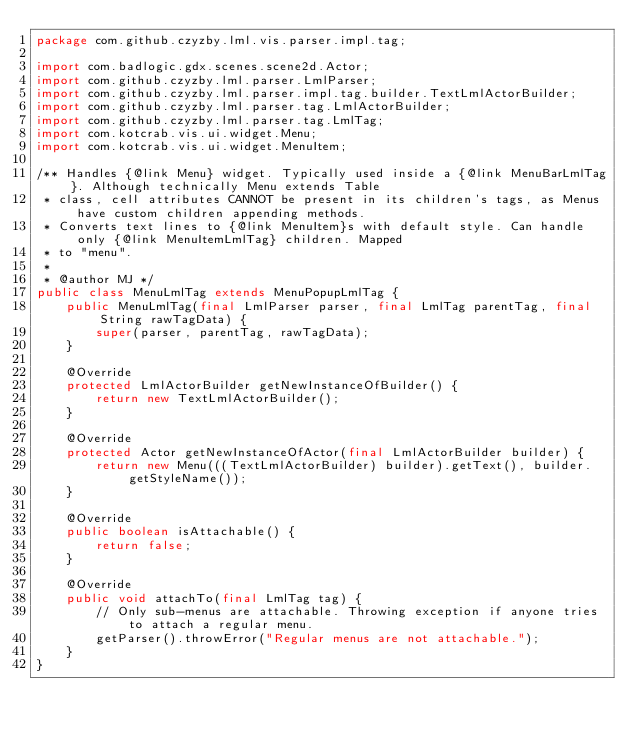Convert code to text. <code><loc_0><loc_0><loc_500><loc_500><_Java_>package com.github.czyzby.lml.vis.parser.impl.tag;

import com.badlogic.gdx.scenes.scene2d.Actor;
import com.github.czyzby.lml.parser.LmlParser;
import com.github.czyzby.lml.parser.impl.tag.builder.TextLmlActorBuilder;
import com.github.czyzby.lml.parser.tag.LmlActorBuilder;
import com.github.czyzby.lml.parser.tag.LmlTag;
import com.kotcrab.vis.ui.widget.Menu;
import com.kotcrab.vis.ui.widget.MenuItem;

/** Handles {@link Menu} widget. Typically used inside a {@link MenuBarLmlTag}. Although technically Menu extends Table
 * class, cell attributes CANNOT be present in its children's tags, as Menus have custom children appending methods.
 * Converts text lines to {@link MenuItem}s with default style. Can handle only {@link MenuItemLmlTag} children. Mapped
 * to "menu".
 *
 * @author MJ */
public class MenuLmlTag extends MenuPopupLmlTag {
    public MenuLmlTag(final LmlParser parser, final LmlTag parentTag, final String rawTagData) {
        super(parser, parentTag, rawTagData);
    }

    @Override
    protected LmlActorBuilder getNewInstanceOfBuilder() {
        return new TextLmlActorBuilder();
    }

    @Override
    protected Actor getNewInstanceOfActor(final LmlActorBuilder builder) {
        return new Menu(((TextLmlActorBuilder) builder).getText(), builder.getStyleName());
    }

    @Override
    public boolean isAttachable() {
        return false;
    }

    @Override
    public void attachTo(final LmlTag tag) {
        // Only sub-menus are attachable. Throwing exception if anyone tries to attach a regular menu.
        getParser().throwError("Regular menus are not attachable.");
    }
}
</code> 